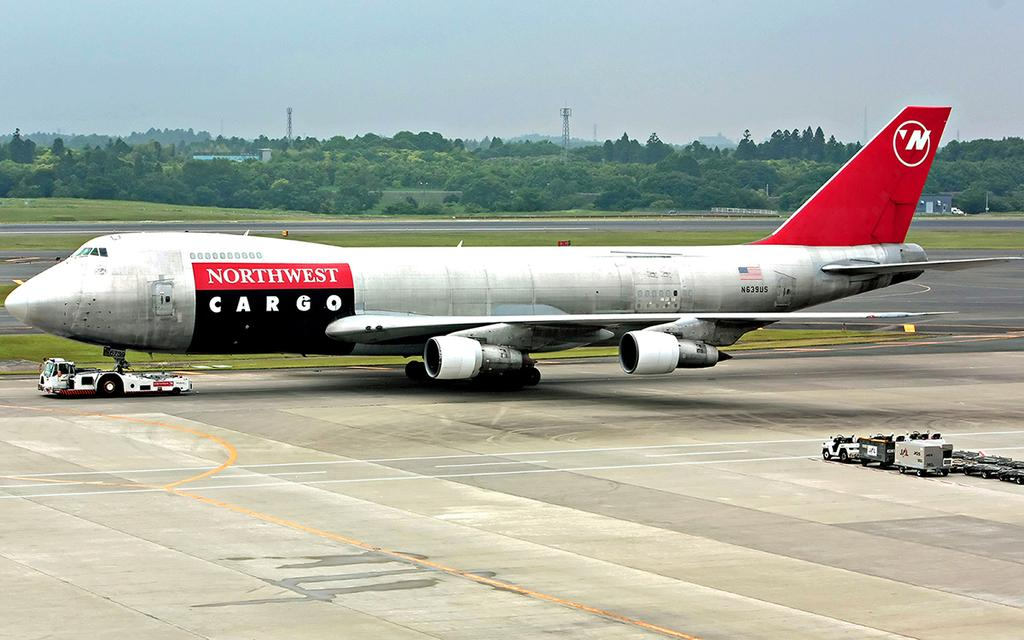<image>
Share a concise interpretation of the image provided. A Northwest Cargo plane is sitting on the runway. 